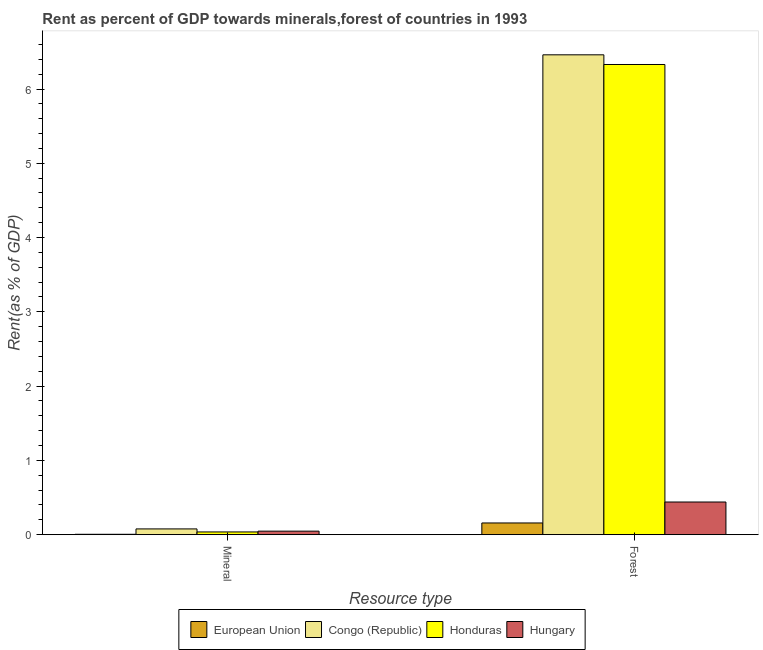How many groups of bars are there?
Give a very brief answer. 2. Are the number of bars per tick equal to the number of legend labels?
Ensure brevity in your answer.  Yes. Are the number of bars on each tick of the X-axis equal?
Provide a short and direct response. Yes. How many bars are there on the 1st tick from the left?
Keep it short and to the point. 4. How many bars are there on the 1st tick from the right?
Provide a short and direct response. 4. What is the label of the 1st group of bars from the left?
Ensure brevity in your answer.  Mineral. What is the mineral rent in Hungary?
Your answer should be very brief. 0.05. Across all countries, what is the maximum forest rent?
Offer a very short reply. 6.46. Across all countries, what is the minimum forest rent?
Keep it short and to the point. 0.16. In which country was the mineral rent maximum?
Offer a terse response. Congo (Republic). What is the total mineral rent in the graph?
Make the answer very short. 0.17. What is the difference between the forest rent in Congo (Republic) and that in European Union?
Provide a short and direct response. 6.3. What is the difference between the forest rent in European Union and the mineral rent in Honduras?
Your answer should be very brief. 0.12. What is the average mineral rent per country?
Make the answer very short. 0.04. What is the difference between the mineral rent and forest rent in European Union?
Offer a very short reply. -0.15. In how many countries, is the forest rent greater than 0.6000000000000001 %?
Your answer should be very brief. 2. What is the ratio of the mineral rent in European Union to that in Hungary?
Offer a terse response. 0.11. What does the 3rd bar from the left in Forest represents?
Ensure brevity in your answer.  Honduras. What does the 1st bar from the right in Forest represents?
Make the answer very short. Hungary. How many bars are there?
Provide a short and direct response. 8. Are all the bars in the graph horizontal?
Your answer should be very brief. No. What is the difference between two consecutive major ticks on the Y-axis?
Provide a short and direct response. 1. Does the graph contain any zero values?
Your answer should be very brief. No. Does the graph contain grids?
Provide a succinct answer. No. How are the legend labels stacked?
Provide a succinct answer. Horizontal. What is the title of the graph?
Your answer should be compact. Rent as percent of GDP towards minerals,forest of countries in 1993. Does "Serbia" appear as one of the legend labels in the graph?
Offer a terse response. No. What is the label or title of the X-axis?
Make the answer very short. Resource type. What is the label or title of the Y-axis?
Your answer should be very brief. Rent(as % of GDP). What is the Rent(as % of GDP) of European Union in Mineral?
Ensure brevity in your answer.  0.01. What is the Rent(as % of GDP) of Congo (Republic) in Mineral?
Give a very brief answer. 0.08. What is the Rent(as % of GDP) of Honduras in Mineral?
Keep it short and to the point. 0.04. What is the Rent(as % of GDP) of Hungary in Mineral?
Make the answer very short. 0.05. What is the Rent(as % of GDP) of European Union in Forest?
Your response must be concise. 0.16. What is the Rent(as % of GDP) in Congo (Republic) in Forest?
Ensure brevity in your answer.  6.46. What is the Rent(as % of GDP) of Honduras in Forest?
Provide a short and direct response. 6.33. What is the Rent(as % of GDP) of Hungary in Forest?
Your answer should be very brief. 0.44. Across all Resource type, what is the maximum Rent(as % of GDP) in European Union?
Provide a succinct answer. 0.16. Across all Resource type, what is the maximum Rent(as % of GDP) of Congo (Republic)?
Your answer should be compact. 6.46. Across all Resource type, what is the maximum Rent(as % of GDP) of Honduras?
Provide a short and direct response. 6.33. Across all Resource type, what is the maximum Rent(as % of GDP) in Hungary?
Your answer should be compact. 0.44. Across all Resource type, what is the minimum Rent(as % of GDP) of European Union?
Your answer should be compact. 0.01. Across all Resource type, what is the minimum Rent(as % of GDP) of Congo (Republic)?
Provide a short and direct response. 0.08. Across all Resource type, what is the minimum Rent(as % of GDP) of Honduras?
Make the answer very short. 0.04. Across all Resource type, what is the minimum Rent(as % of GDP) of Hungary?
Provide a short and direct response. 0.05. What is the total Rent(as % of GDP) of European Union in the graph?
Ensure brevity in your answer.  0.16. What is the total Rent(as % of GDP) of Congo (Republic) in the graph?
Provide a short and direct response. 6.54. What is the total Rent(as % of GDP) in Honduras in the graph?
Provide a short and direct response. 6.37. What is the total Rent(as % of GDP) in Hungary in the graph?
Give a very brief answer. 0.49. What is the difference between the Rent(as % of GDP) in European Union in Mineral and that in Forest?
Ensure brevity in your answer.  -0.15. What is the difference between the Rent(as % of GDP) in Congo (Republic) in Mineral and that in Forest?
Your response must be concise. -6.38. What is the difference between the Rent(as % of GDP) in Honduras in Mineral and that in Forest?
Your answer should be compact. -6.29. What is the difference between the Rent(as % of GDP) in Hungary in Mineral and that in Forest?
Provide a succinct answer. -0.39. What is the difference between the Rent(as % of GDP) in European Union in Mineral and the Rent(as % of GDP) in Congo (Republic) in Forest?
Provide a succinct answer. -6.45. What is the difference between the Rent(as % of GDP) in European Union in Mineral and the Rent(as % of GDP) in Honduras in Forest?
Your answer should be compact. -6.32. What is the difference between the Rent(as % of GDP) in European Union in Mineral and the Rent(as % of GDP) in Hungary in Forest?
Provide a succinct answer. -0.43. What is the difference between the Rent(as % of GDP) of Congo (Republic) in Mineral and the Rent(as % of GDP) of Honduras in Forest?
Give a very brief answer. -6.25. What is the difference between the Rent(as % of GDP) of Congo (Republic) in Mineral and the Rent(as % of GDP) of Hungary in Forest?
Your response must be concise. -0.36. What is the difference between the Rent(as % of GDP) in Honduras in Mineral and the Rent(as % of GDP) in Hungary in Forest?
Keep it short and to the point. -0.4. What is the average Rent(as % of GDP) of European Union per Resource type?
Give a very brief answer. 0.08. What is the average Rent(as % of GDP) of Congo (Republic) per Resource type?
Your answer should be very brief. 3.27. What is the average Rent(as % of GDP) of Honduras per Resource type?
Provide a short and direct response. 3.18. What is the average Rent(as % of GDP) in Hungary per Resource type?
Keep it short and to the point. 0.24. What is the difference between the Rent(as % of GDP) in European Union and Rent(as % of GDP) in Congo (Republic) in Mineral?
Provide a short and direct response. -0.07. What is the difference between the Rent(as % of GDP) in European Union and Rent(as % of GDP) in Honduras in Mineral?
Provide a succinct answer. -0.03. What is the difference between the Rent(as % of GDP) of European Union and Rent(as % of GDP) of Hungary in Mineral?
Give a very brief answer. -0.04. What is the difference between the Rent(as % of GDP) of Congo (Republic) and Rent(as % of GDP) of Honduras in Mineral?
Give a very brief answer. 0.04. What is the difference between the Rent(as % of GDP) in Congo (Republic) and Rent(as % of GDP) in Hungary in Mineral?
Offer a very short reply. 0.03. What is the difference between the Rent(as % of GDP) of Honduras and Rent(as % of GDP) of Hungary in Mineral?
Your response must be concise. -0.01. What is the difference between the Rent(as % of GDP) of European Union and Rent(as % of GDP) of Congo (Republic) in Forest?
Your response must be concise. -6.3. What is the difference between the Rent(as % of GDP) of European Union and Rent(as % of GDP) of Honduras in Forest?
Your response must be concise. -6.17. What is the difference between the Rent(as % of GDP) of European Union and Rent(as % of GDP) of Hungary in Forest?
Your response must be concise. -0.28. What is the difference between the Rent(as % of GDP) of Congo (Republic) and Rent(as % of GDP) of Honduras in Forest?
Ensure brevity in your answer.  0.13. What is the difference between the Rent(as % of GDP) of Congo (Republic) and Rent(as % of GDP) of Hungary in Forest?
Provide a short and direct response. 6.02. What is the difference between the Rent(as % of GDP) in Honduras and Rent(as % of GDP) in Hungary in Forest?
Offer a very short reply. 5.89. What is the ratio of the Rent(as % of GDP) in European Union in Mineral to that in Forest?
Give a very brief answer. 0.03. What is the ratio of the Rent(as % of GDP) of Congo (Republic) in Mineral to that in Forest?
Your response must be concise. 0.01. What is the ratio of the Rent(as % of GDP) in Honduras in Mineral to that in Forest?
Provide a succinct answer. 0.01. What is the ratio of the Rent(as % of GDP) in Hungary in Mineral to that in Forest?
Offer a terse response. 0.11. What is the difference between the highest and the second highest Rent(as % of GDP) in European Union?
Offer a terse response. 0.15. What is the difference between the highest and the second highest Rent(as % of GDP) of Congo (Republic)?
Give a very brief answer. 6.38. What is the difference between the highest and the second highest Rent(as % of GDP) in Honduras?
Your response must be concise. 6.29. What is the difference between the highest and the second highest Rent(as % of GDP) of Hungary?
Provide a succinct answer. 0.39. What is the difference between the highest and the lowest Rent(as % of GDP) of European Union?
Make the answer very short. 0.15. What is the difference between the highest and the lowest Rent(as % of GDP) of Congo (Republic)?
Offer a terse response. 6.38. What is the difference between the highest and the lowest Rent(as % of GDP) in Honduras?
Your answer should be very brief. 6.29. What is the difference between the highest and the lowest Rent(as % of GDP) of Hungary?
Give a very brief answer. 0.39. 